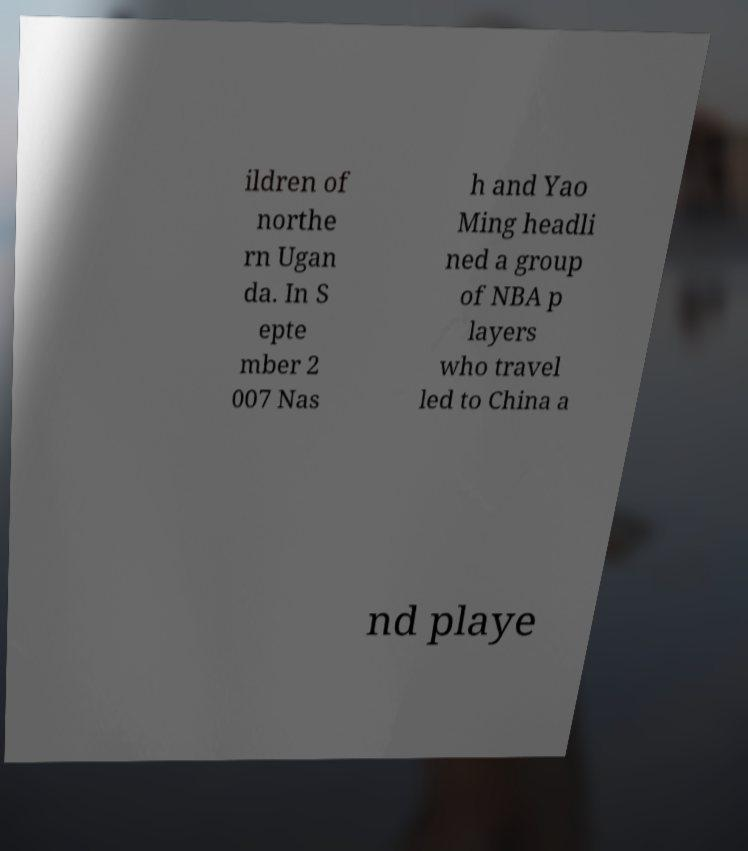I need the written content from this picture converted into text. Can you do that? ildren of northe rn Ugan da. In S epte mber 2 007 Nas h and Yao Ming headli ned a group of NBA p layers who travel led to China a nd playe 